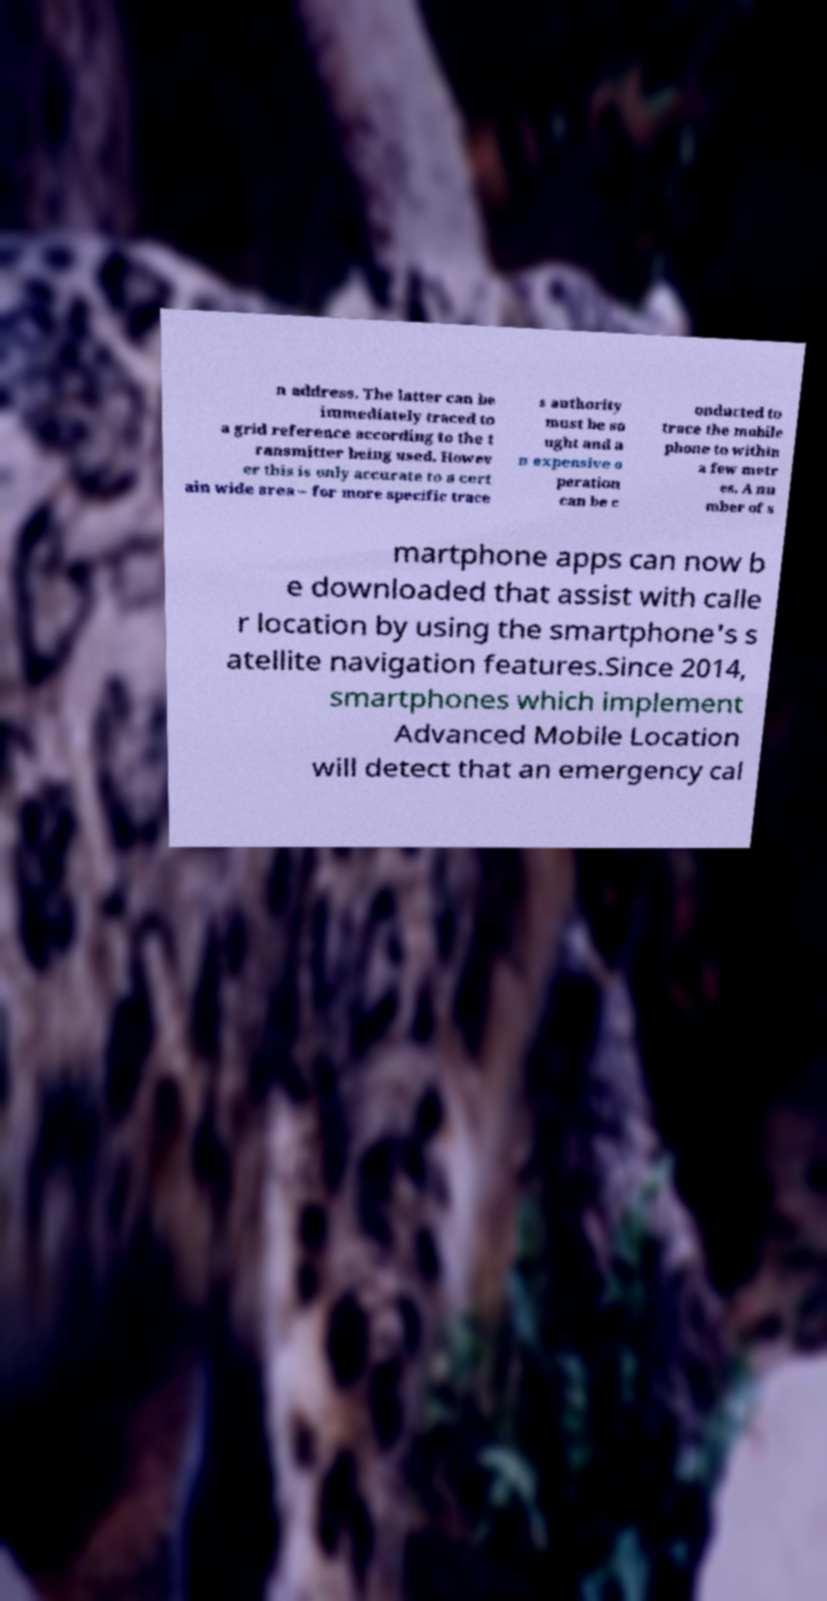Please identify and transcribe the text found in this image. n address. The latter can be immediately traced to a grid reference according to the t ransmitter being used. Howev er this is only accurate to a cert ain wide area – for more specific trace s authority must be so ught and a n expensive o peration can be c onducted to trace the mobile phone to within a few metr es. A nu mber of s martphone apps can now b e downloaded that assist with calle r location by using the smartphone's s atellite navigation features.Since 2014, smartphones which implement Advanced Mobile Location will detect that an emergency cal 